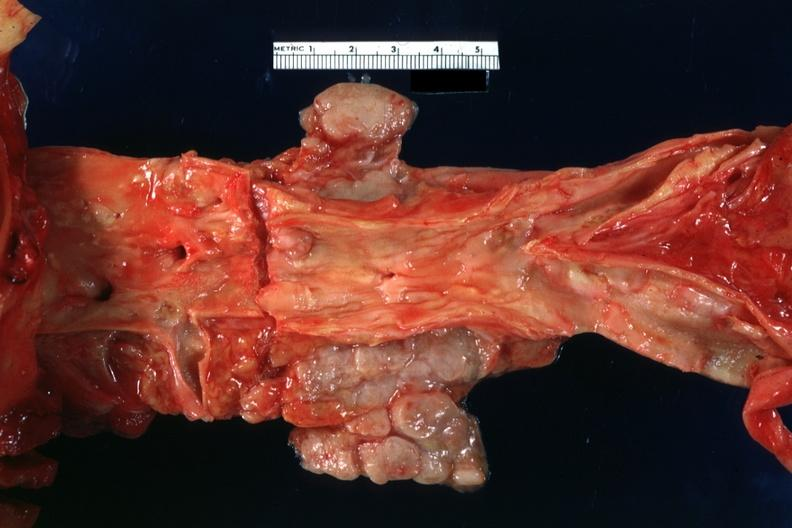s another fiber other frame present?
Answer the question using a single word or phrase. No 